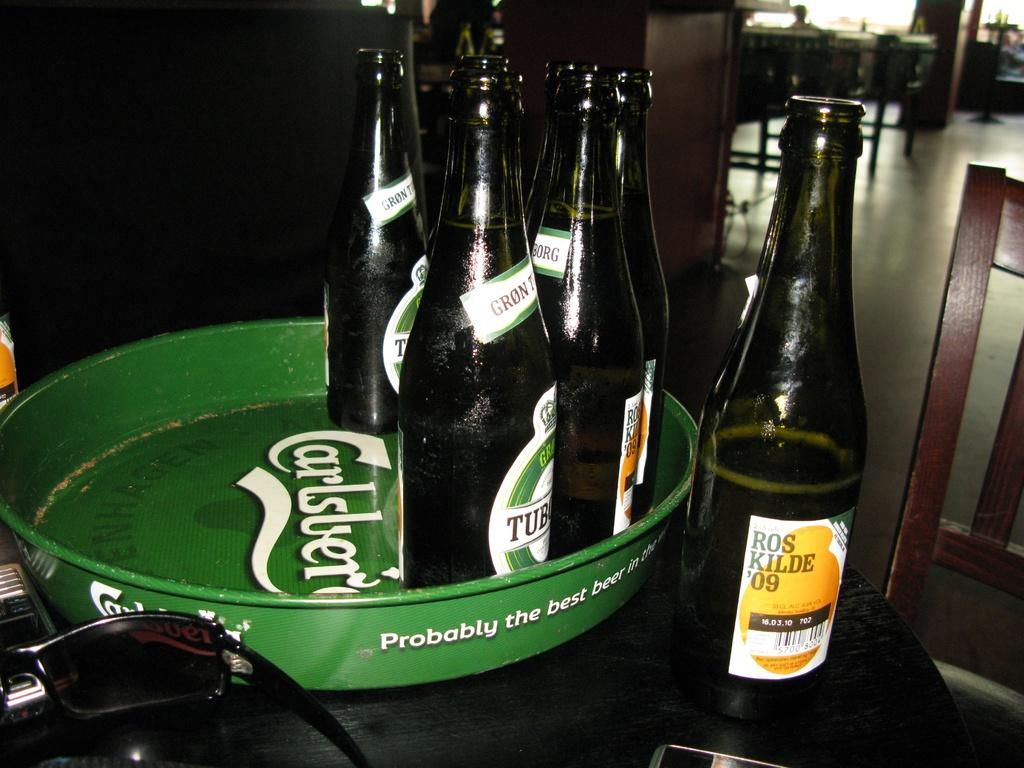<image>
Give a short and clear explanation of the subsequent image. A bottle of Ros Kilde '09 sitting on a table next to a tray of several other bottles of beer. 